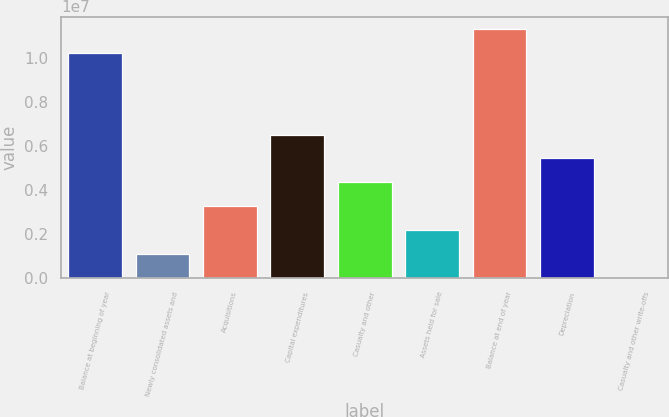<chart> <loc_0><loc_0><loc_500><loc_500><bar_chart><fcel>Balance at beginning of year<fcel>Newly consolidated assets and<fcel>Acquisitions<fcel>Capital expenditures<fcel>Casualty and other<fcel>Assets held for sale<fcel>Balance at end of year<fcel>Depreciation<fcel>Casualty and other write-offs<nl><fcel>1.02483e+07<fcel>1.09019e+06<fcel>3.26683e+06<fcel>6.5318e+06<fcel>4.35516e+06<fcel>2.17851e+06<fcel>1.13366e+07<fcel>5.44348e+06<fcel>1865<nl></chart> 